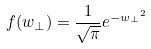Convert formula to latex. <formula><loc_0><loc_0><loc_500><loc_500>f ( w _ { \perp } ) = \frac { 1 } { \sqrt { \pi } } e ^ { - { w _ { \perp } } ^ { 2 } }</formula> 